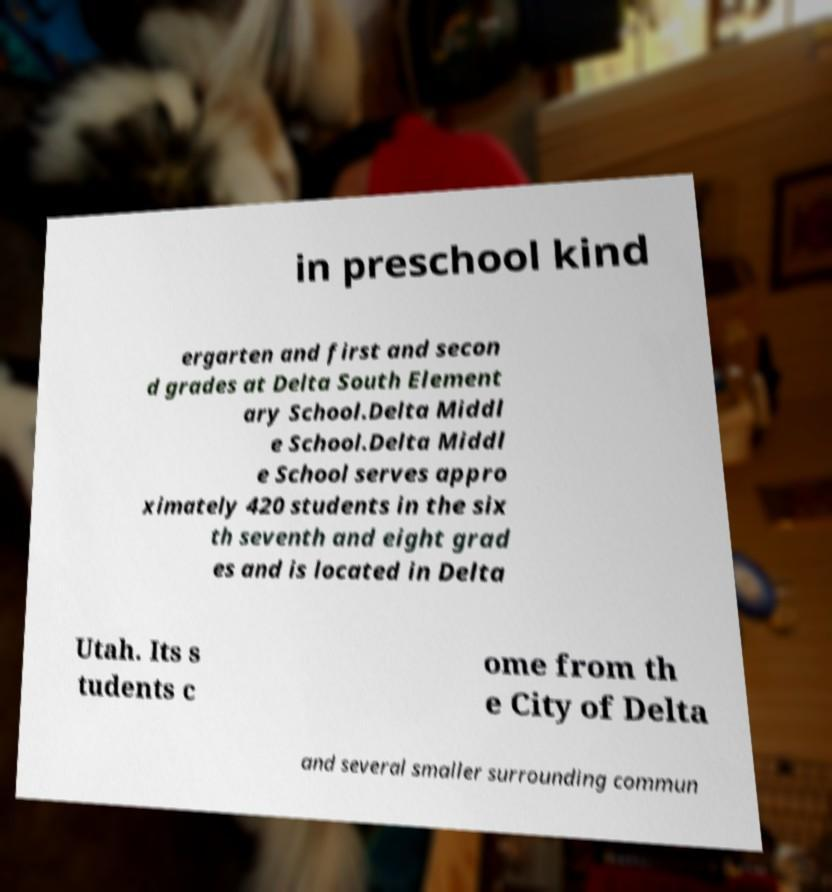Could you assist in decoding the text presented in this image and type it out clearly? in preschool kind ergarten and first and secon d grades at Delta South Element ary School.Delta Middl e School.Delta Middl e School serves appro ximately 420 students in the six th seventh and eight grad es and is located in Delta Utah. Its s tudents c ome from th e City of Delta and several smaller surrounding commun 